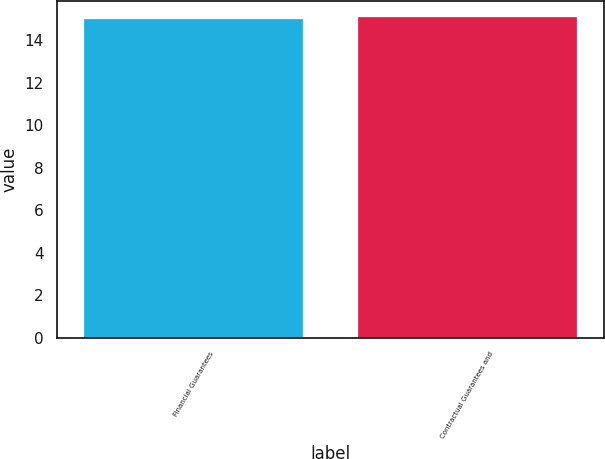Convert chart to OTSL. <chart><loc_0><loc_0><loc_500><loc_500><bar_chart><fcel>Financial Guarantees<fcel>Contractual Guarantees and<nl><fcel>15<fcel>15.1<nl></chart> 